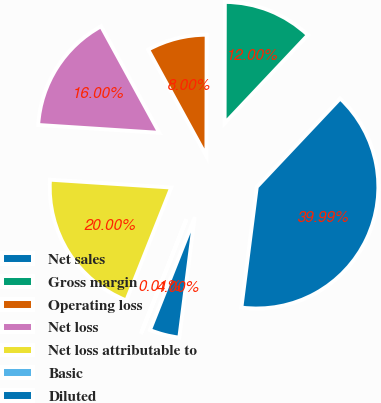Convert chart to OTSL. <chart><loc_0><loc_0><loc_500><loc_500><pie_chart><fcel>Net sales<fcel>Gross margin<fcel>Operating loss<fcel>Net loss<fcel>Net loss attributable to<fcel>Basic<fcel>Diluted<nl><fcel>39.99%<fcel>12.0%<fcel>8.0%<fcel>16.0%<fcel>20.0%<fcel>0.01%<fcel>4.0%<nl></chart> 